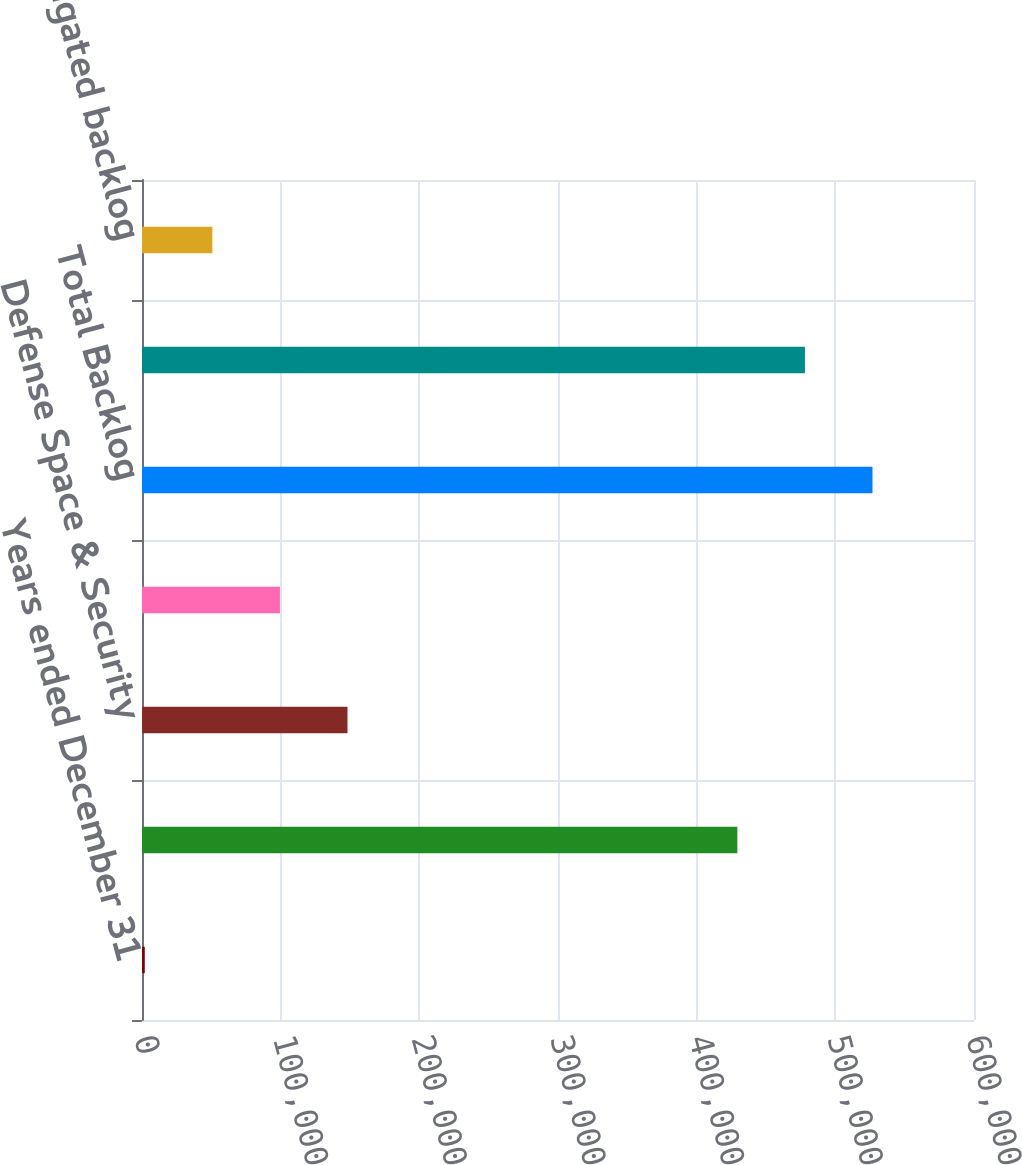Convert chart to OTSL. <chart><loc_0><loc_0><loc_500><loc_500><bar_chart><fcel>Years ended December 31<fcel>Commercial Airplanes<fcel>Defense Space & Security<fcel>Global Services<fcel>Total Backlog<fcel>Contractual backlog<fcel>Unobligated backlog<nl><fcel>2015<fcel>429346<fcel>148200<fcel>99471.8<fcel>526803<fcel>478074<fcel>50743.4<nl></chart> 